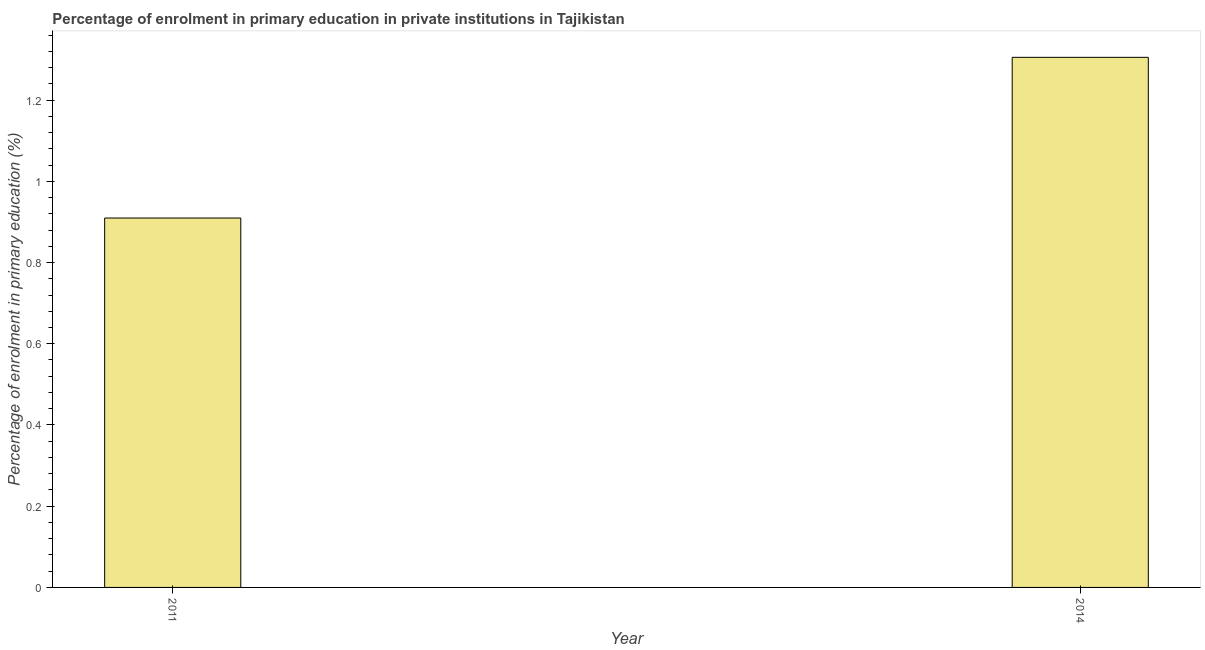Does the graph contain any zero values?
Give a very brief answer. No. Does the graph contain grids?
Provide a short and direct response. No. What is the title of the graph?
Make the answer very short. Percentage of enrolment in primary education in private institutions in Tajikistan. What is the label or title of the Y-axis?
Provide a succinct answer. Percentage of enrolment in primary education (%). What is the enrolment percentage in primary education in 2011?
Your answer should be compact. 0.91. Across all years, what is the maximum enrolment percentage in primary education?
Your answer should be very brief. 1.31. Across all years, what is the minimum enrolment percentage in primary education?
Provide a succinct answer. 0.91. In which year was the enrolment percentage in primary education minimum?
Your answer should be compact. 2011. What is the sum of the enrolment percentage in primary education?
Give a very brief answer. 2.21. What is the difference between the enrolment percentage in primary education in 2011 and 2014?
Provide a short and direct response. -0.4. What is the average enrolment percentage in primary education per year?
Give a very brief answer. 1.11. What is the median enrolment percentage in primary education?
Keep it short and to the point. 1.11. In how many years, is the enrolment percentage in primary education greater than 0.2 %?
Provide a short and direct response. 2. Do a majority of the years between 2014 and 2011 (inclusive) have enrolment percentage in primary education greater than 1.28 %?
Ensure brevity in your answer.  No. What is the ratio of the enrolment percentage in primary education in 2011 to that in 2014?
Keep it short and to the point. 0.7. Is the enrolment percentage in primary education in 2011 less than that in 2014?
Offer a very short reply. Yes. How many bars are there?
Ensure brevity in your answer.  2. Are all the bars in the graph horizontal?
Provide a succinct answer. No. How many years are there in the graph?
Your response must be concise. 2. What is the difference between two consecutive major ticks on the Y-axis?
Your answer should be very brief. 0.2. Are the values on the major ticks of Y-axis written in scientific E-notation?
Provide a short and direct response. No. What is the Percentage of enrolment in primary education (%) in 2011?
Keep it short and to the point. 0.91. What is the Percentage of enrolment in primary education (%) of 2014?
Your answer should be compact. 1.31. What is the difference between the Percentage of enrolment in primary education (%) in 2011 and 2014?
Your answer should be compact. -0.4. What is the ratio of the Percentage of enrolment in primary education (%) in 2011 to that in 2014?
Offer a very short reply. 0.7. 